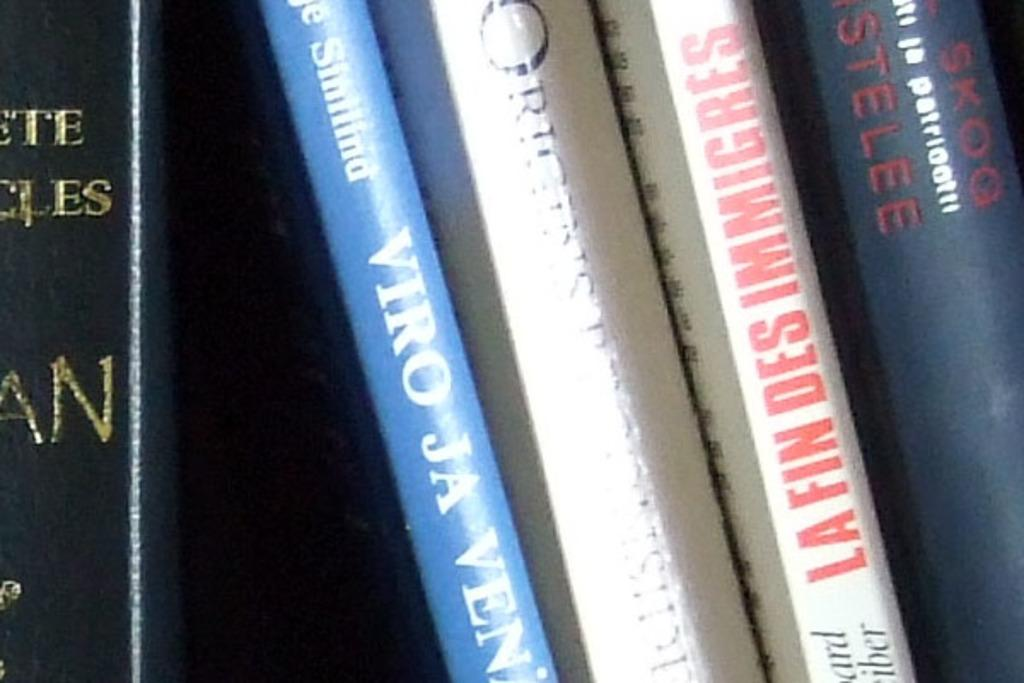<image>
Render a clear and concise summary of the photo. the word viro is on the side of a book 